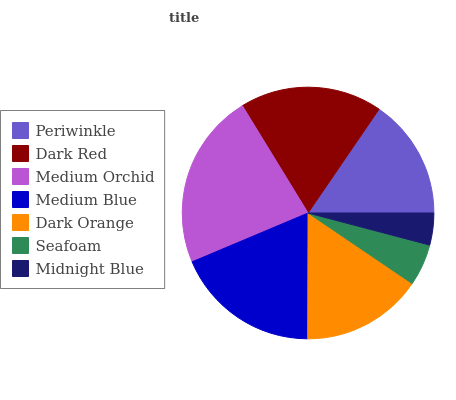Is Midnight Blue the minimum?
Answer yes or no. Yes. Is Medium Orchid the maximum?
Answer yes or no. Yes. Is Dark Red the minimum?
Answer yes or no. No. Is Dark Red the maximum?
Answer yes or no. No. Is Dark Red greater than Periwinkle?
Answer yes or no. Yes. Is Periwinkle less than Dark Red?
Answer yes or no. Yes. Is Periwinkle greater than Dark Red?
Answer yes or no. No. Is Dark Red less than Periwinkle?
Answer yes or no. No. Is Dark Orange the high median?
Answer yes or no. Yes. Is Dark Orange the low median?
Answer yes or no. Yes. Is Periwinkle the high median?
Answer yes or no. No. Is Dark Red the low median?
Answer yes or no. No. 